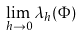<formula> <loc_0><loc_0><loc_500><loc_500>\lim _ { h \to 0 } \lambda _ { h } ( \Phi )</formula> 